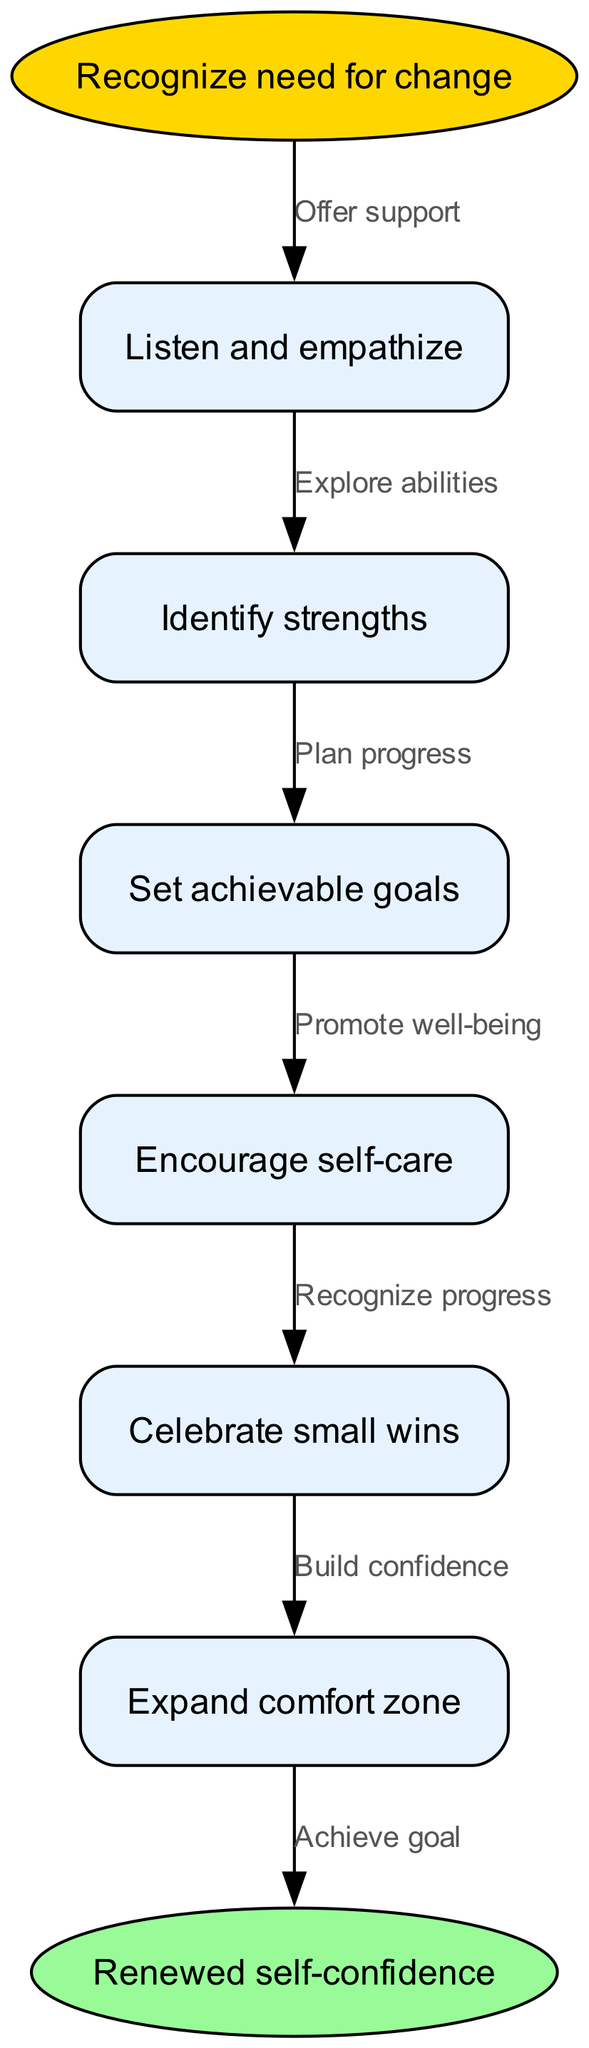What is the starting step in rebuilding self-confidence? The first node in the flow indicates that the starting step is "Recognize need for change". This is where the process begins.
Answer: Recognize need for change How many nodes are there in the diagram? Counting each distinct node listed, including the start and end, there are a total of 7 nodes in the diagram: 1 start node, 5 intermediate nodes, and 1 end node.
Answer: 7 What action is supposed to follow "Listen and empathize"? Looking at the diagram, the next action after "Listen and empathize" is "Identify strengths", as it is directly connected by an edge indicating the flow of steps.
Answer: Identify strengths What node comes after "Set achievable goals"? From the flow structure, the node that follows "Set achievable goals" is "Encourage self-care", as this is the next step in the progression.
Answer: Encourage self-care Which two nodes are connected by the edge labeled "Recognize progress"? The edge labeled "Recognize progress" connects the nodes "Encourage self-care" and "Celebrate small wins". This indicates they are directly linked in the flow.
Answer: Encourage self-care, Celebrate small wins Why is the edge from "Celebrate small wins" significant? The edge from "Celebrate small wins" to "Expand comfort zone" is significant because it represents the concept of building confidence as a result of recognizing smaller achievements, thus demonstrating growth throughout the process.
Answer: Build confidence How does one achieve renewed self-confidence according to the diagram? Achieving renewed self-confidence is indicated as the final step after all prior actions, directly connecting through the last edge in the flow, showing that it's the culmination of all prior efforts.
Answer: Renewed self-confidence 